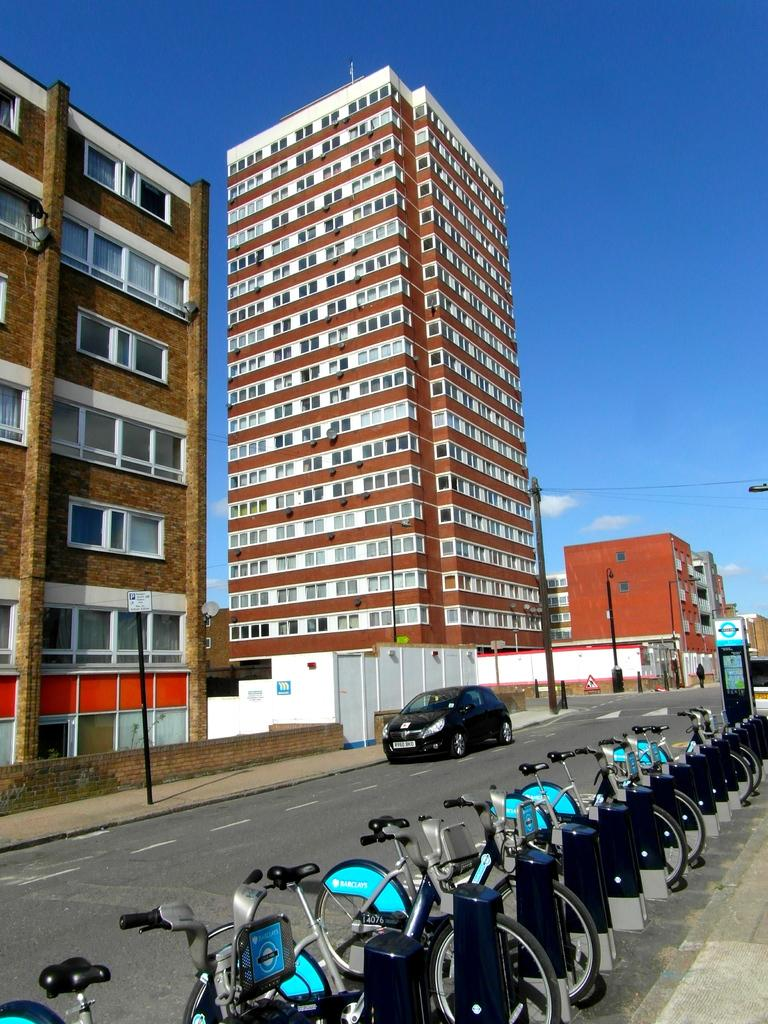What type of vehicles are on the road in the image? There are bicycles and a car on the road in the image. What feature do the buildings in the image have? The buildings in the image have windows. What can be seen in the background of the image? The sky is visible in the background of the image. What is present in the sky? Clouds are present in the sky. How do the bicycles use their hands to navigate the road in the image? The bicycles do not have hands, as they are inanimate objects. The people riding the bicycles use their hands to steer and control the bicycles. 